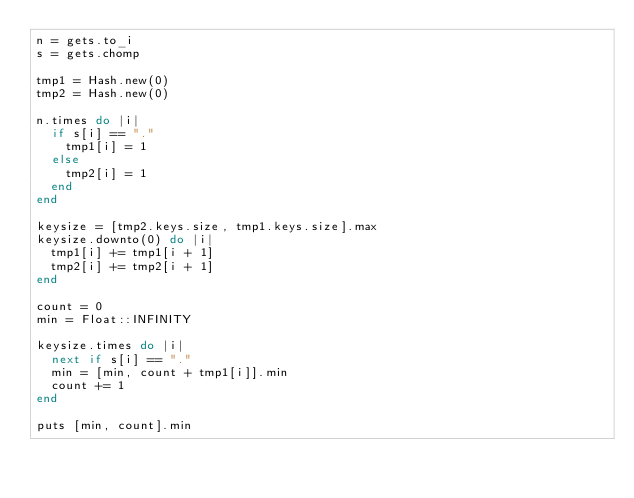Convert code to text. <code><loc_0><loc_0><loc_500><loc_500><_Ruby_>n = gets.to_i
s = gets.chomp

tmp1 = Hash.new(0)
tmp2 = Hash.new(0)

n.times do |i|
  if s[i] == "."
    tmp1[i] = 1
  else
    tmp2[i] = 1
  end
end

keysize = [tmp2.keys.size, tmp1.keys.size].max
keysize.downto(0) do |i|
  tmp1[i] += tmp1[i + 1]
  tmp2[i] += tmp2[i + 1]
end

count = 0
min = Float::INFINITY

keysize.times do |i|
  next if s[i] == "."
  min = [min, count + tmp1[i]].min
  count += 1
end

puts [min, count].min
</code> 